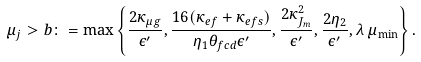Convert formula to latex. <formula><loc_0><loc_0><loc_500><loc_500>\mu _ { j } > b \colon = \max \left \{ \frac { 2 \kappa _ { \mu g } } { \epsilon ^ { \prime } } , \frac { 1 6 ( \kappa _ { e f } + \kappa _ { e f s } ) } { \eta _ { 1 } \theta _ { f c d } \epsilon ^ { \prime } } , \frac { 2 \kappa _ { J _ { m } } ^ { 2 } } { \epsilon ^ { \prime } } , \frac { 2 \eta _ { 2 } } { \epsilon ^ { \prime } } , \lambda \, \mu _ { \min } \right \} .</formula> 